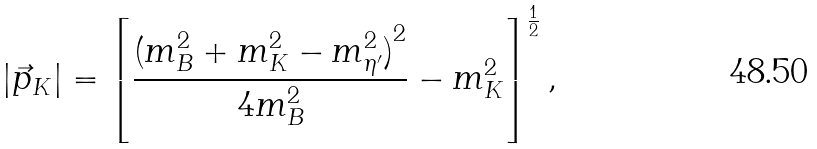<formula> <loc_0><loc_0><loc_500><loc_500>| \vec { p } _ { K } | = { \left [ \frac { { ( m _ { B } ^ { 2 } + m _ { K } ^ { 2 } - m _ { \eta ^ { \prime } } ^ { 2 } ) } ^ { 2 } } { 4 m _ { B } ^ { 2 } } - m _ { K } ^ { 2 } \right ] } ^ { \frac { 1 } { 2 } } \, ,</formula> 